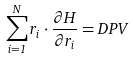Convert formula to latex. <formula><loc_0><loc_0><loc_500><loc_500>\sum _ { i = 1 } ^ { N } { r } _ { i } \cdot \frac { \partial H } { \partial { r } _ { i } } = D P V</formula> 